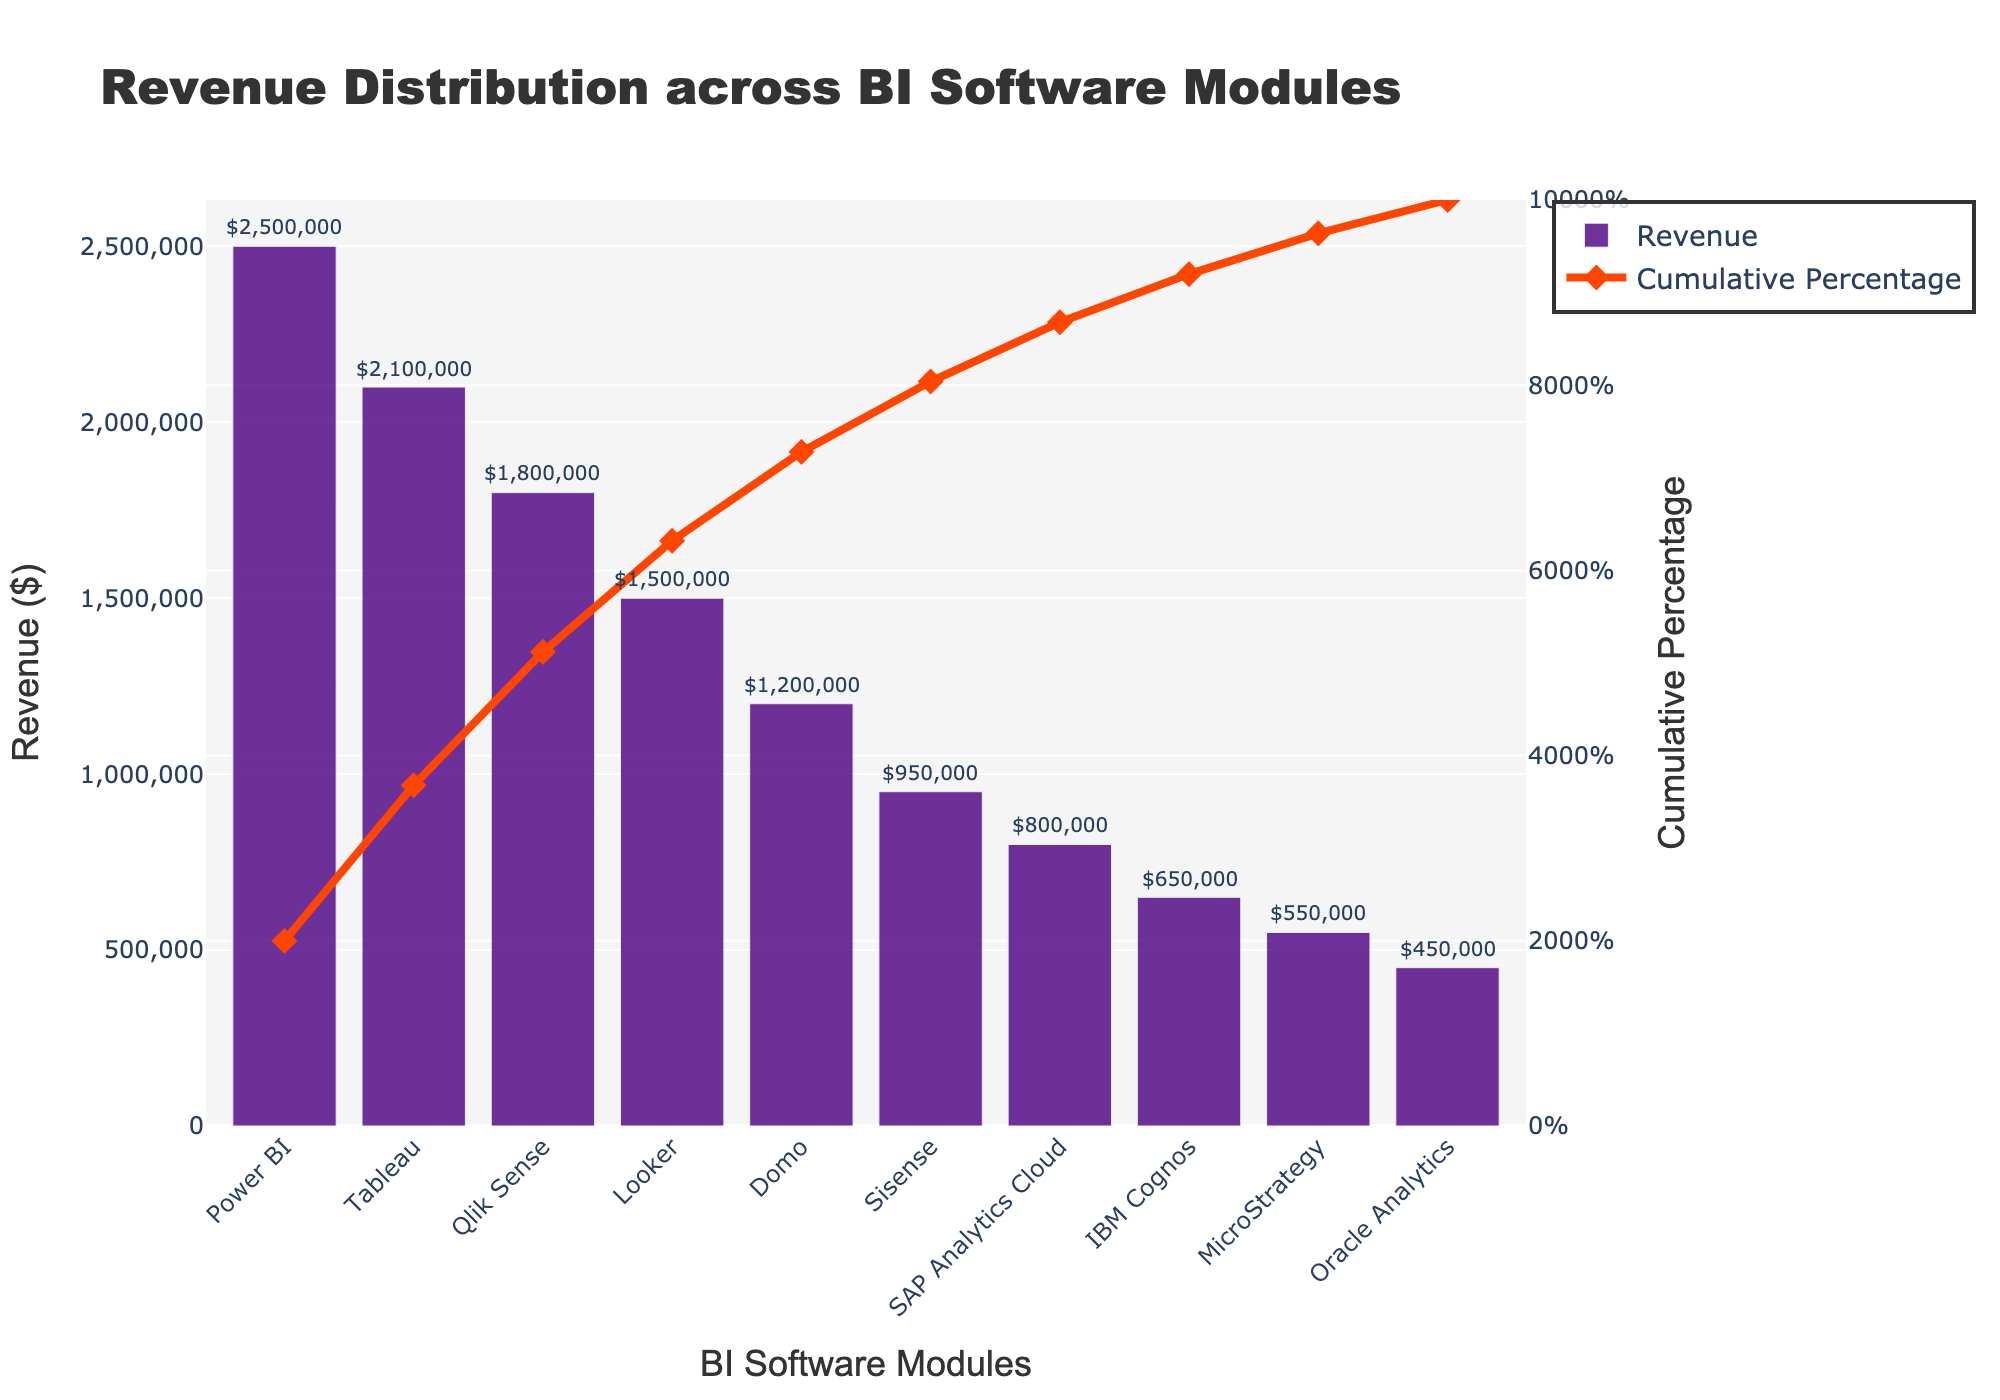What is the title of the Pareto chart? The title is usually positioned at the top center of the chart and is surrounded by additional visual and text elements that help clarify the chart's purpose. For this chart, the title explicitly describes the main aspect being visualized.
Answer: Revenue Distribution across BI Software Modules Which BI software module generated the highest revenue? The highest revenue can be identified by looking at the tallest bar in the bar chart section of the Pareto chart. The label below this bar will indicate the product name.
Answer: Power BI What percentage of the total cumulative revenue is captured by the top three BI software modules? To compute this, identify the cumulative percentage corresponding to the third bar (Looker). This value directly provides the cumulative contribution of the top three products.
Answer: 72.91% How does the revenue of Tableau compare to Qlik Sense? Locate the bars representing Tableau and Qlik Sense. The heights of the bars directly indicate their revenues. A quick reference to the annotations on top of the bars will confirm the exact revenues for comparison.
Answer: Tableau has a higher revenue than Qlik Sense ($2,100,000 vs $1,800,000) What is the cumulative percentage after the top five BI software modules? To find this, check the cumulative line till the fifth bar (Sisense). The cumulative percentage value at the fifth product provides the answer.
Answer: 89.09% How does MicroStrategy rank in terms of revenue compared to other products? All products can be ranked by the descending heights of their bars. Counting from the tallest bar to MicroStrategy's bar will determine its rank.
Answer: 9th What is the approximate difference in revenue between the highest and lowest earning BI software modules? Identify the tallest and shortest bars representing the highest and lowest revenues. Subtract the revenue value of Oracle Analytics (the shortest bar) from Power BI (the tallest bar).
Answer: $2,050,000 What are the y-axis titles for both revenue and cumulative percentage? The y-axis on the left indicates revenue in monetary terms and is labeled accordingly. The y-axis on the right shows the cumulative percentage, also clearly defined.
Answer: Revenue ($) and Cumulative Percentage Which BI software modules contribute to approximately 50% of the total revenue? Following the cumulative percentage line to the 50% mark, trace down to the x-axis labels to identify the products until this cumulative percentage is reached.
Answer: Power BI, Tableau, and part of Qlik Sense What color is used to represent the cumulative percentage line and what symbol marks the data points? The visual attributes of the cumulative percentage line include its color and the type of marker used for data points. Inspecting the chart reveals these characteristics.
Answer: Red line and diamond symbols 